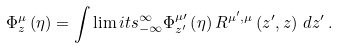Convert formula to latex. <formula><loc_0><loc_0><loc_500><loc_500>\Phi _ { z } ^ { \mu } \left ( \eta \right ) = \int \lim i t s _ { - \infty } ^ { \infty } \Phi _ { z ^ { \prime } } ^ { \mu \prime } \left ( \eta \right ) R ^ { \mu ^ { \prime } , \mu } \left ( z ^ { \prime } , z \right ) \, d z ^ { \prime } \, .</formula> 